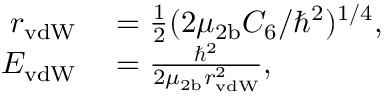Convert formula to latex. <formula><loc_0><loc_0><loc_500><loc_500>\begin{array} { r l } { r _ { v d W } } & = \frac { 1 } { 2 } ( 2 \mu _ { 2 b } C _ { 6 } / \hbar { ^ } { 2 } ) ^ { 1 / 4 } , } \\ { E _ { v d W } } & = \frac { \hbar { ^ } { 2 } } { 2 \mu _ { 2 b } r _ { v d W } ^ { 2 } } , } \end{array}</formula> 